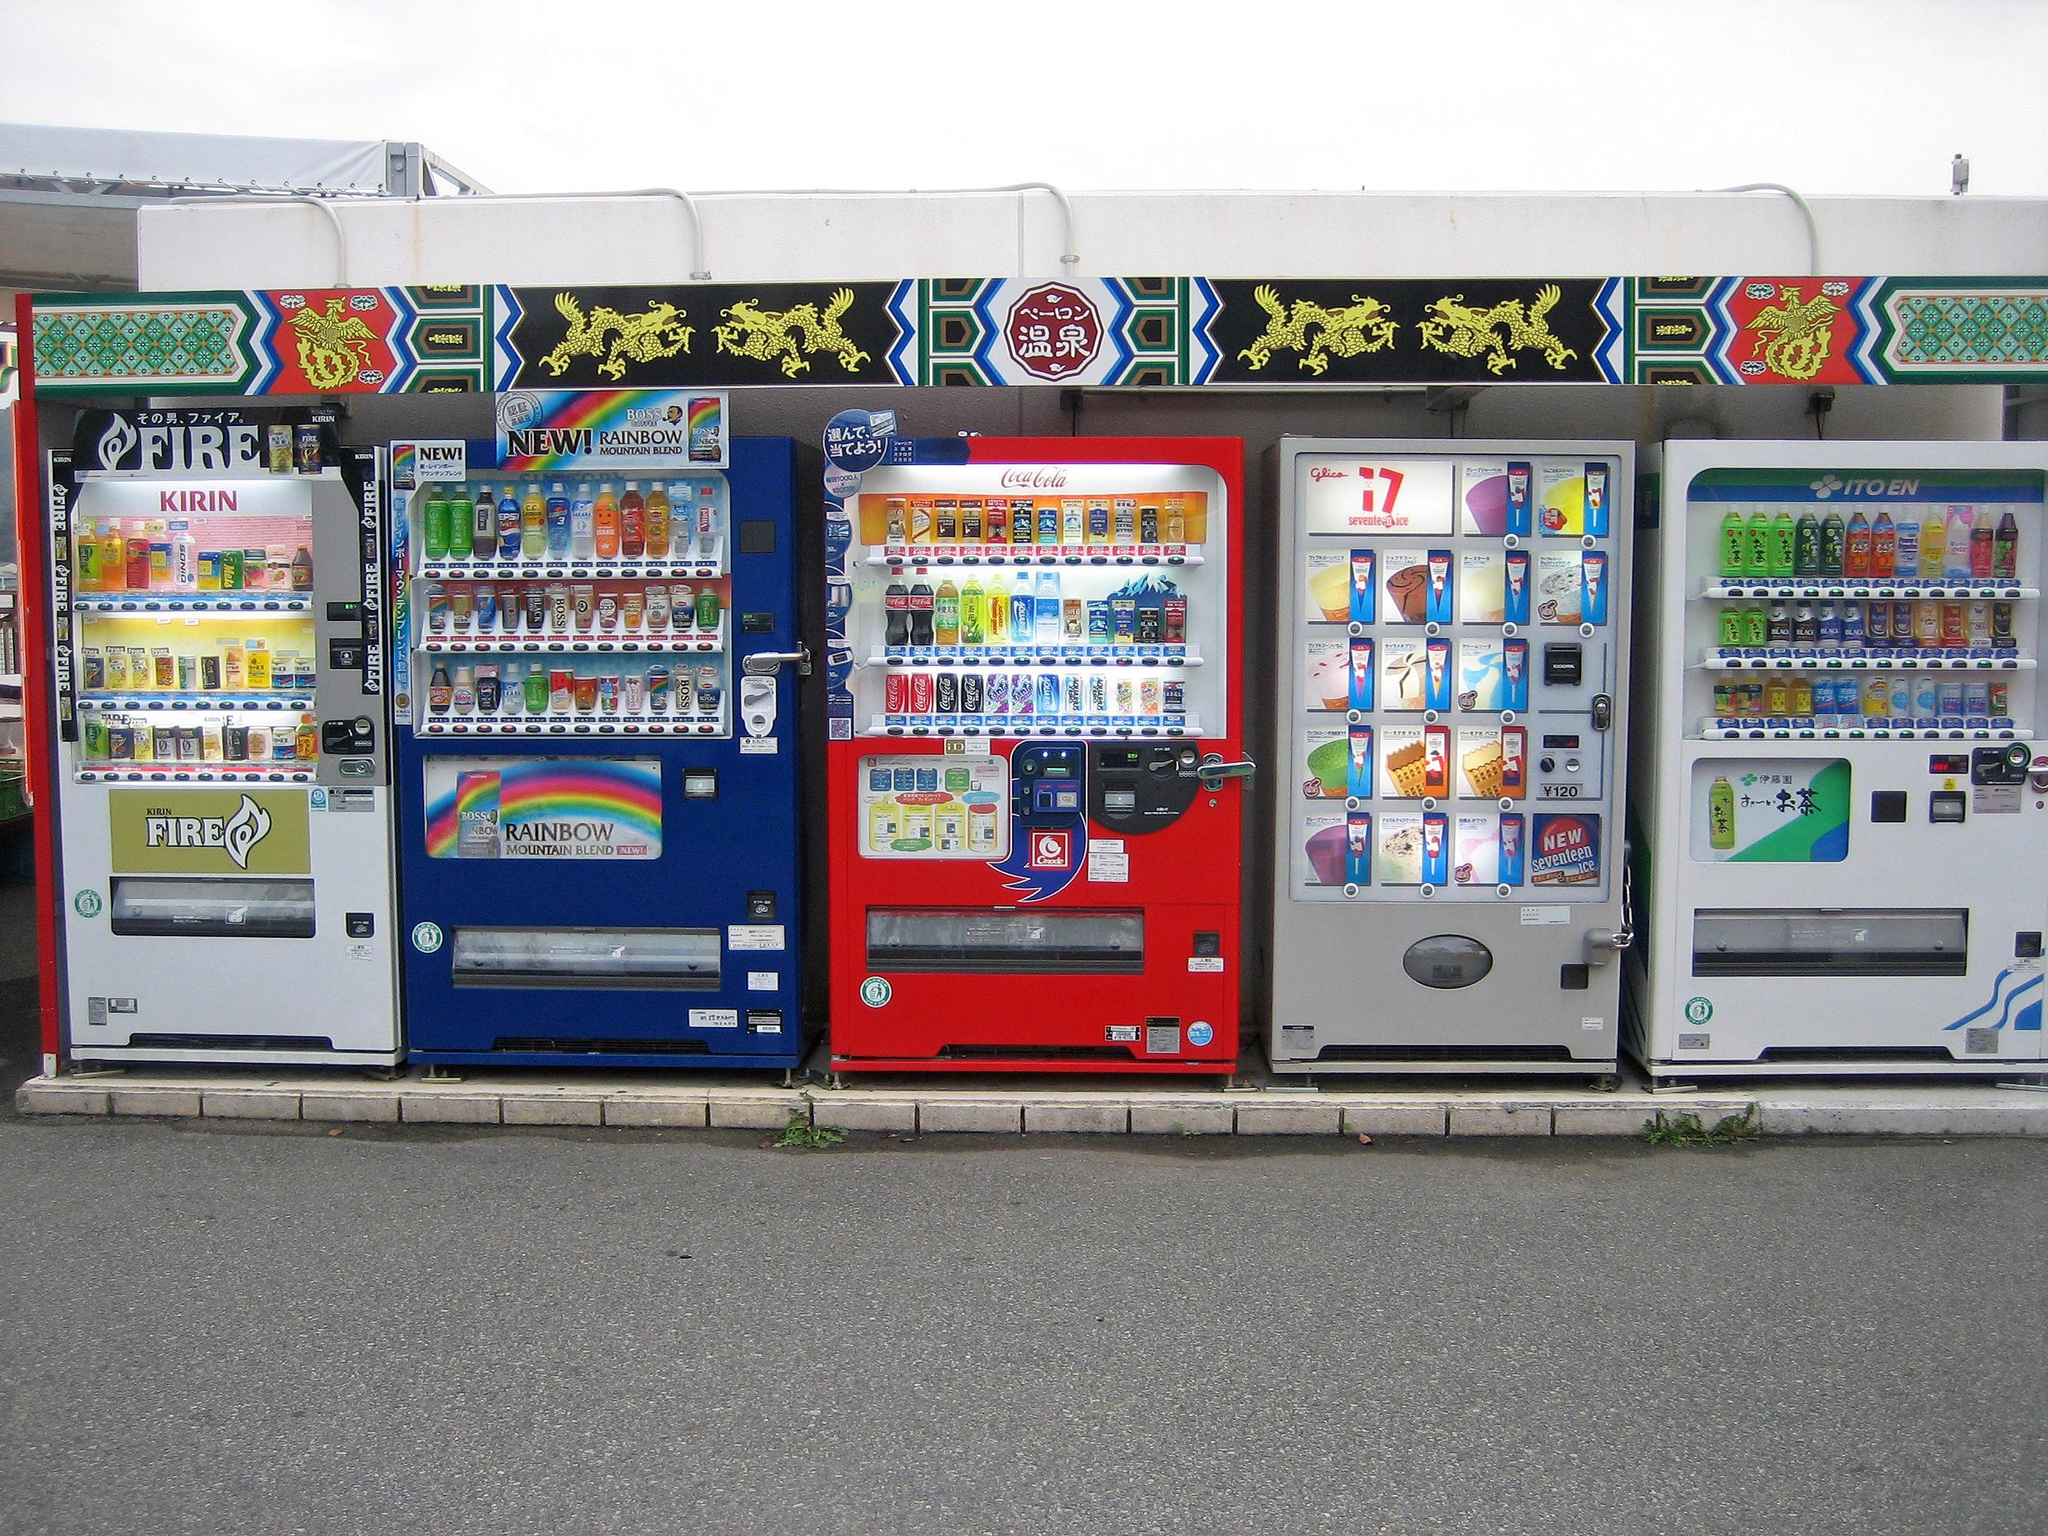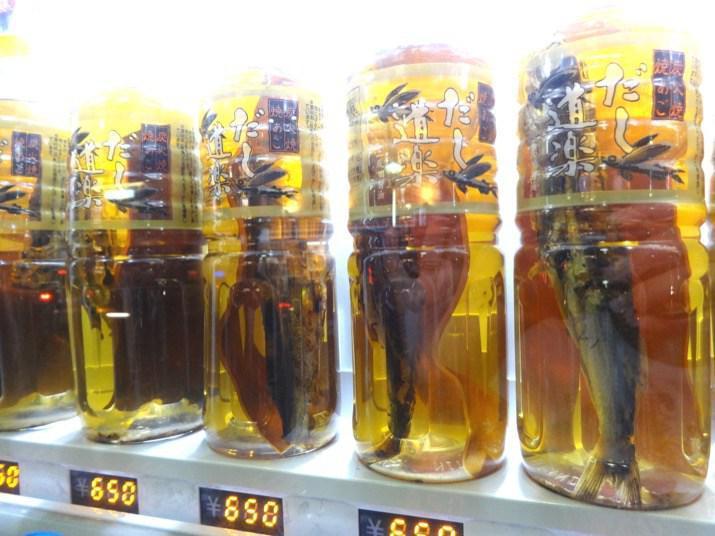The first image is the image on the left, the second image is the image on the right. Examine the images to the left and right. Is the description "There is a row of red, white, and blue vending machines with pavement in front of them." accurate? Answer yes or no. Yes. The first image is the image on the left, the second image is the image on the right. Evaluate the accuracy of this statement regarding the images: "There are no more than five machines.". Is it true? Answer yes or no. No. 